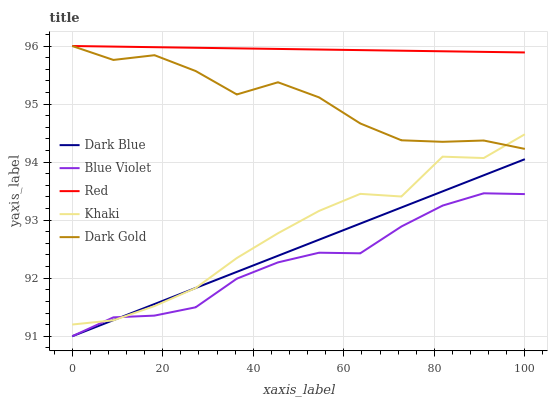Does Blue Violet have the minimum area under the curve?
Answer yes or no. Yes. Does Red have the maximum area under the curve?
Answer yes or no. Yes. Does Khaki have the minimum area under the curve?
Answer yes or no. No. Does Khaki have the maximum area under the curve?
Answer yes or no. No. Is Red the smoothest?
Answer yes or no. Yes. Is Khaki the roughest?
Answer yes or no. Yes. Is Khaki the smoothest?
Answer yes or no. No. Is Red the roughest?
Answer yes or no. No. Does Khaki have the lowest value?
Answer yes or no. No. Does Dark Gold have the highest value?
Answer yes or no. Yes. Does Khaki have the highest value?
Answer yes or no. No. Is Dark Blue less than Red?
Answer yes or no. Yes. Is Dark Gold greater than Blue Violet?
Answer yes or no. Yes. Does Dark Blue intersect Red?
Answer yes or no. No. 